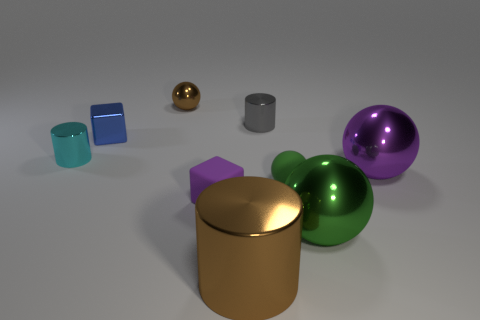There is a big object that is in front of the green metal thing; what is it made of?
Your answer should be very brief. Metal. Is there a blue object that has the same size as the brown cylinder?
Your answer should be very brief. No. Is the color of the metal ball behind the tiny blue object the same as the large metallic cylinder?
Provide a short and direct response. Yes. How many blue things are rubber things or metal balls?
Provide a short and direct response. 0. What number of tiny matte blocks have the same color as the rubber sphere?
Give a very brief answer. 0. Is the cyan object made of the same material as the small green object?
Provide a short and direct response. No. How many green metallic balls are to the left of the small cylinder that is behind the metallic cube?
Offer a very short reply. 0. Does the purple rubber cube have the same size as the green matte object?
Your answer should be compact. Yes. What number of small spheres are made of the same material as the tiny brown thing?
Offer a terse response. 0. There is a rubber object that is the same shape as the tiny blue metal thing; what is its size?
Provide a succinct answer. Small. 